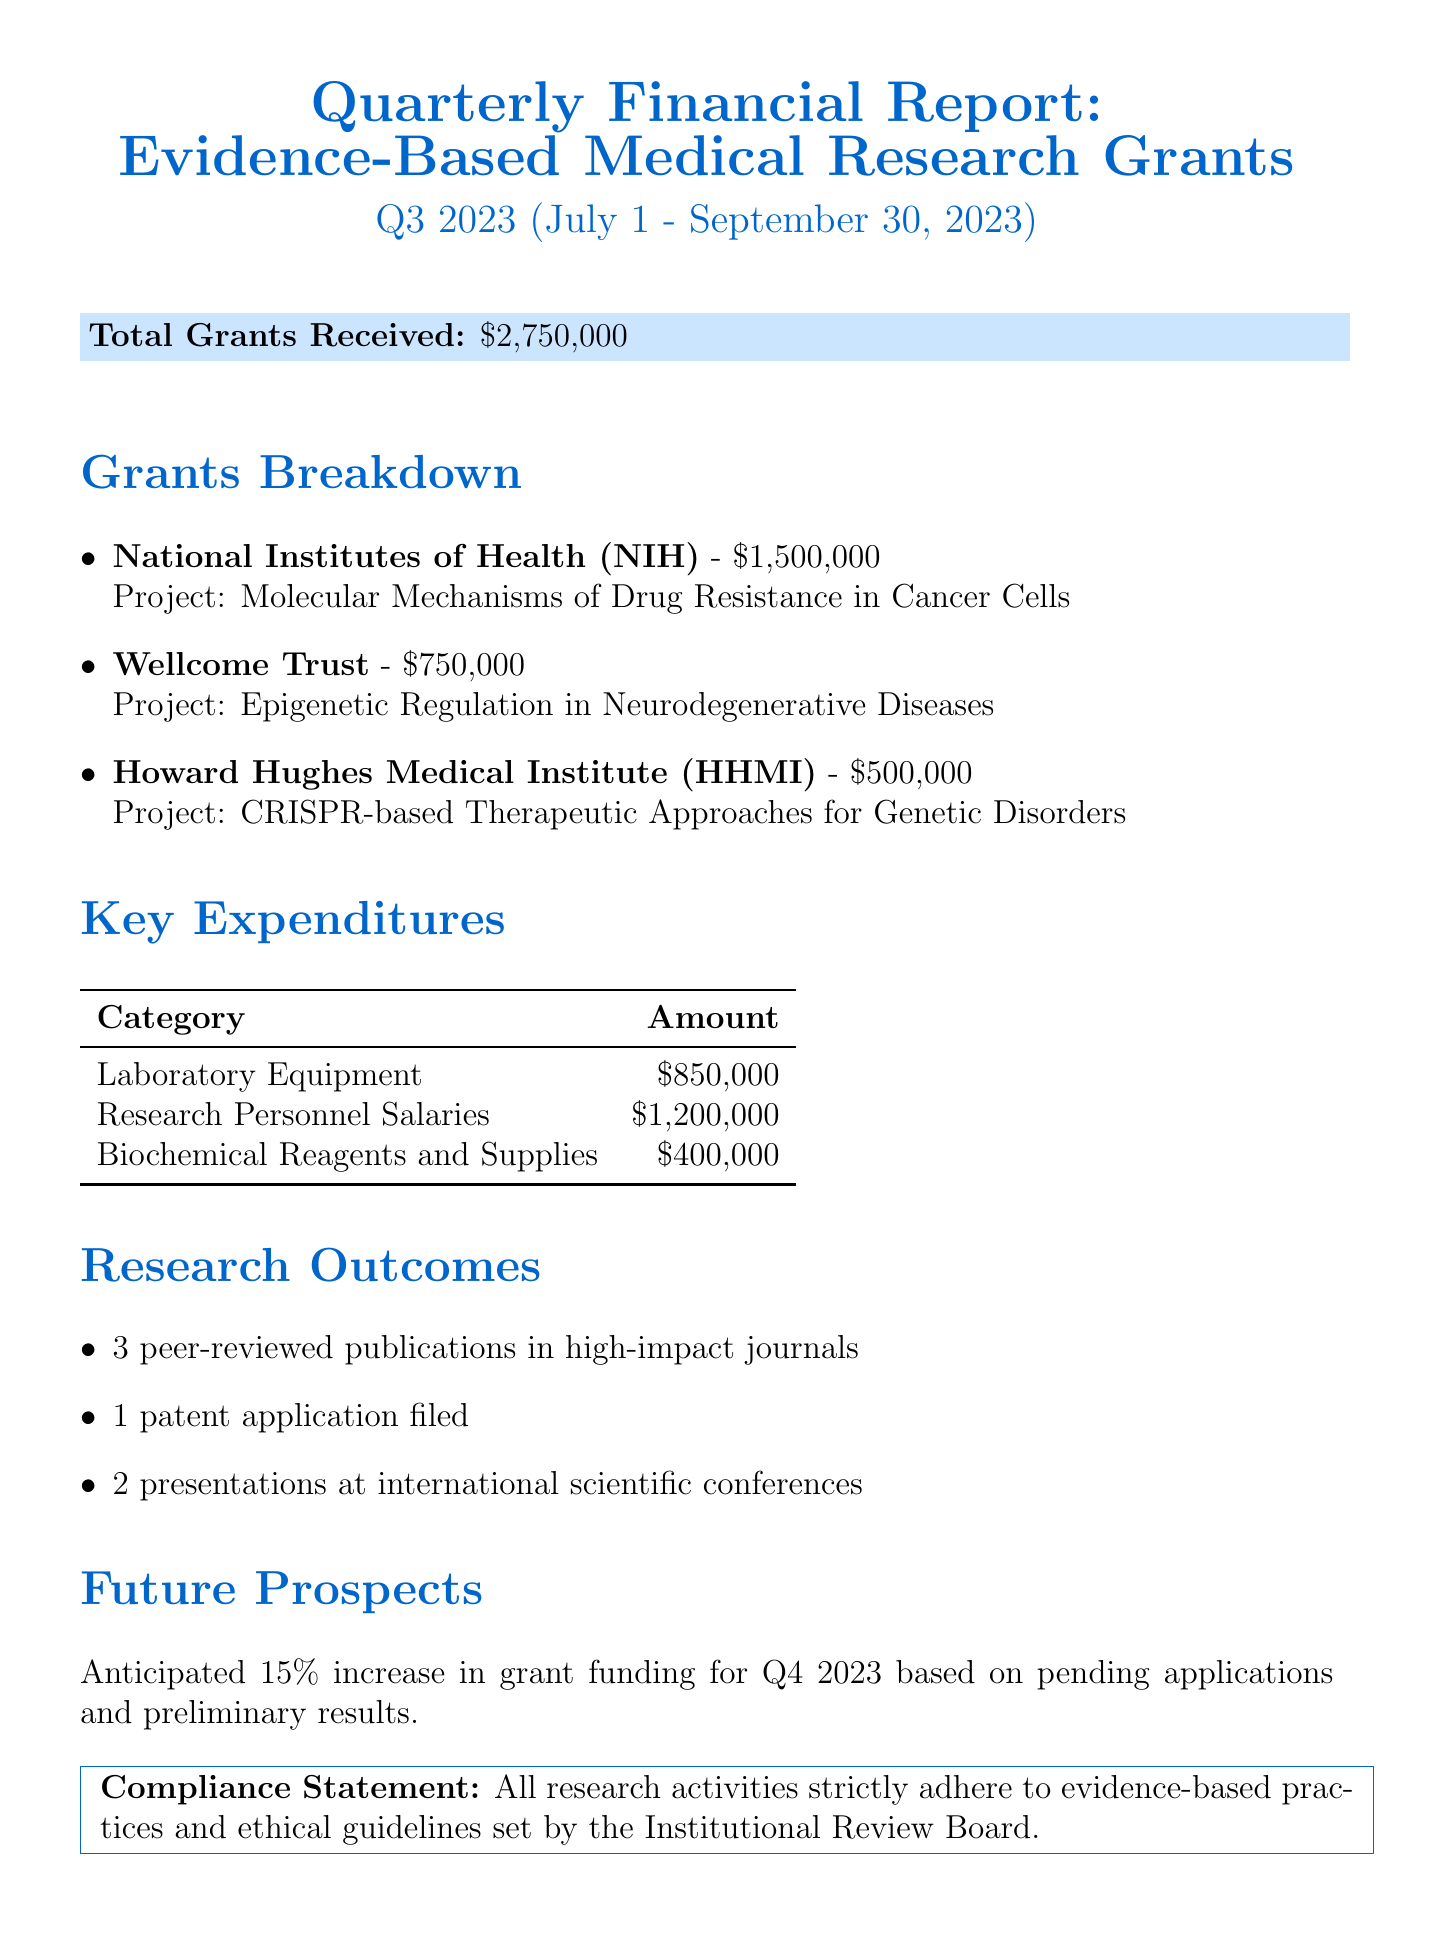What is the reporting period for this financial report? The reporting period is indicated clearly in the document, covering the months from July 1 to September 30, 2023.
Answer: Q3 2023 (July 1 - September 30, 2023) How much total grant funding was received? The total grants received is provided as a single figure in the report.
Answer: $2,750,000 Which organization provided the largest grant? The breakdown of grants reveals the amount from each grantor, identifying the NIH as the largest contributor.
Answer: National Institutes of Health (NIH) What is the amount allocated to laboratory equipment? The key expenditures section lists the amount specifically designated for laboratory equipment.
Answer: $850,000 How many peer-reviewed publications were reported? The research outcomes section specifies the number of peer-reviewed publications resulting from the grants.
Answer: 3 What is the anticipated percentage increase in grant funding for Q4 2023? The future prospects section mentions an expected increase rate, which can be found directly in the report.
Answer: 15% How many presentations were made at international scientific conferences? The research outcomes detail the total number of presentations given at conferences.
Answer: 2 What is the compliance statement regarding research activities? The compliance statement outlines adherence to practices and guidelines, found in the concluding section of the document.
Answer: All research activities strictly adhere to evidence-based practices and ethical guidelines set by the Institutional Review Board What was the total amount allocated to research personnel salaries? The key expenditures specifically states the salaries amount dedicated to research personnel.
Answer: $1,200,000 